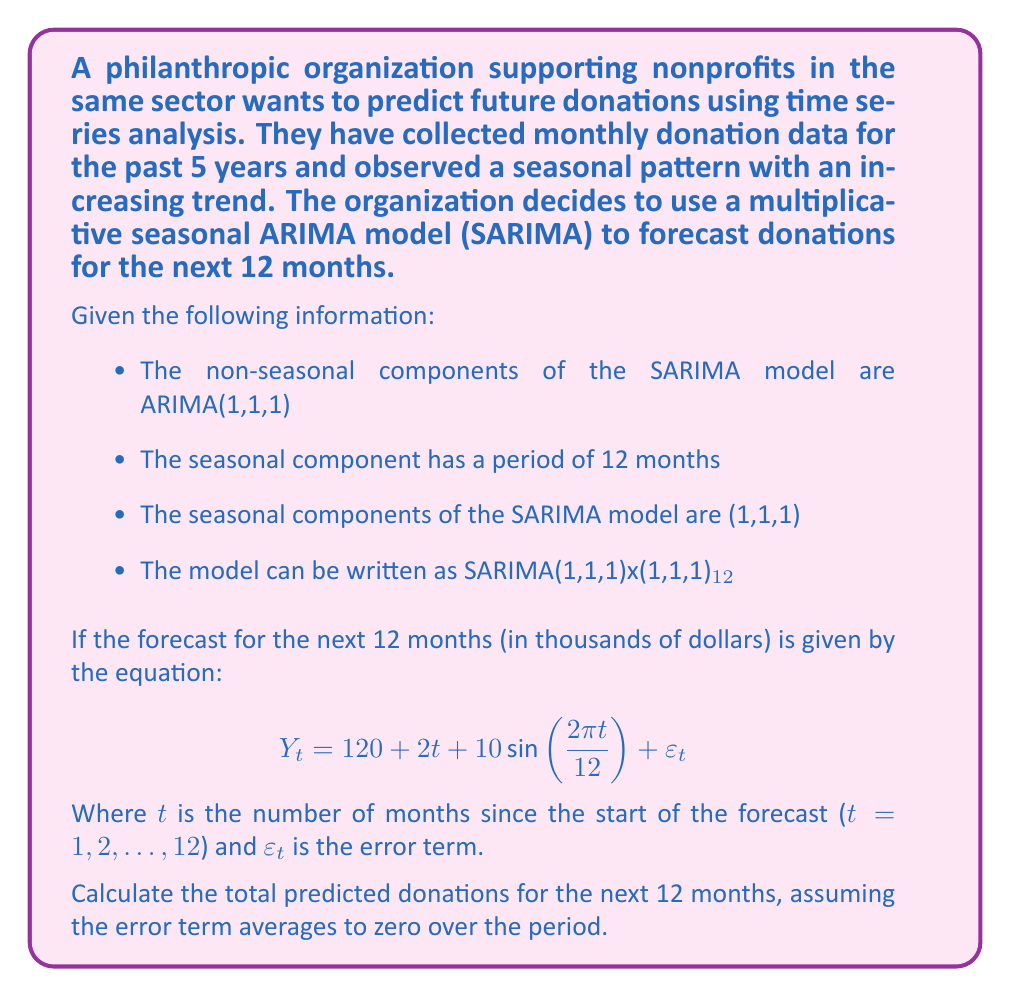Help me with this question. To solve this problem, we need to follow these steps:

1. Understand the given forecast equation:
   $$Y_t = 120 + 2t + 10\sin(\frac{2\pi t}{12}) + \varepsilon_t$$
   
   Here, 120 is the base value, 2t represents the increasing trend, and $10\sin(\frac{2\pi t}{12})$ represents the seasonal component.

2. Ignore the error term $\varepsilon_t$ as we're assuming it averages to zero over the period.

3. Calculate the predicted donation for each month (t = 1 to 12) using the equation.

4. Sum up all the monthly predictions to get the total for the year.

Let's calculate for each month:

Month 1: $Y_1 = 120 + 2(1) + 10\sin(\frac{2\pi(1)}{12}) = 122 + 10\sin(\frac{\pi}{6}) = 127$
Month 2: $Y_2 = 120 + 2(2) + 10\sin(\frac{2\pi(2)}{12}) = 124 + 10\sin(\frac{\pi}{3}) = 132.66$
Month 3: $Y_3 = 120 + 2(3) + 10\sin(\frac{2\pi(3)}{12}) = 126 + 10\sin(\frac{\pi}{2}) = 136$
Month 4: $Y_4 = 120 + 2(4) + 10\sin(\frac{2\pi(4)}{12}) = 128 + 10\sin(\frac{2\pi}{3}) = 136.66$
Month 5: $Y_5 = 120 + 2(5) + 10\sin(\frac{2\pi(5)}{12}) = 130 + 10\sin(\frac{5\pi}{6}) = 135$
Month 6: $Y_6 = 120 + 2(6) + 10\sin(\frac{2\pi(6)}{12}) = 132 + 10\sin(\pi) = 132$
Month 7: $Y_7 = 120 + 2(7) + 10\sin(\frac{2\pi(7)}{12}) = 134 + 10\sin(\frac{7\pi}{6}) = 129$
Month 8: $Y_8 = 120 + 2(8) + 10\sin(\frac{2\pi(8)}{12}) = 136 + 10\sin(\frac{4\pi}{3}) = 127.34$
Month 9: $Y_9 = 120 + 2(9) + 10\sin(\frac{2\pi(9)}{12}) = 138 + 10\sin(\frac{3\pi}{2}) = 128$
Month 10: $Y_{10} = 120 + 2(10) + 10\sin(\frac{2\pi(10)}{12}) = 140 + 10\sin(\frac{5\pi}{3}) = 131.34$
Month 11: $Y_{11} = 120 + 2(11) + 10\sin(\frac{2\pi(11)}{12}) = 142 + 10\sin(\frac{11\pi}{6}) = 137$
Month 12: $Y_{12} = 120 + 2(12) + 10\sin(\frac{2\pi(12)}{12}) = 144 + 10\sin(2\pi) = 144$

Now, we sum up all these values:

Total = 127 + 132.66 + 136 + 136.66 + 135 + 132 + 129 + 127.34 + 128 + 131.34 + 137 + 144 = 1596

Therefore, the total predicted donations for the next 12 months is 1596 thousand dollars, or $1,596,000.
Answer: $1,596,000 